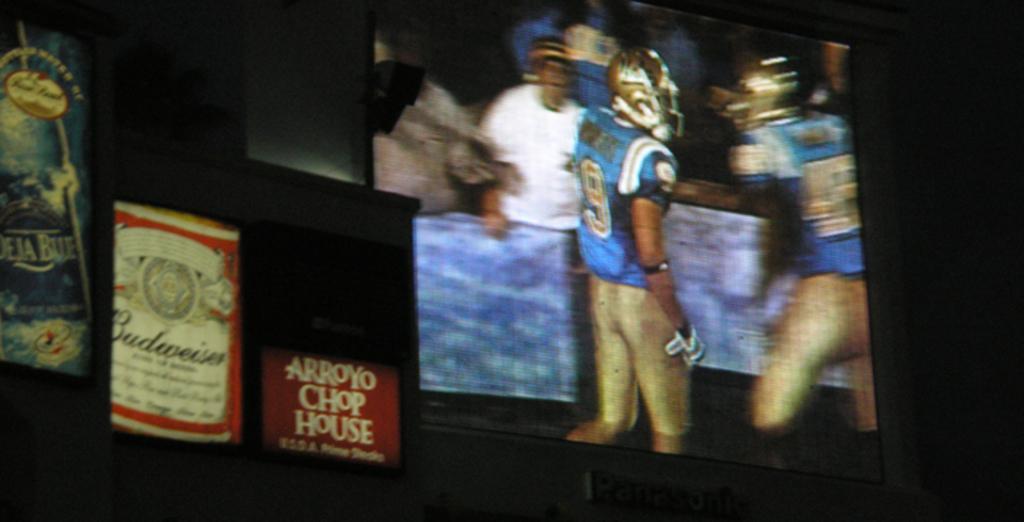How would you summarize this image in a sentence or two? In this image I can see few boards which are blue, red and white in color and the television in which I can see few persons. I can see the wall in the background. 